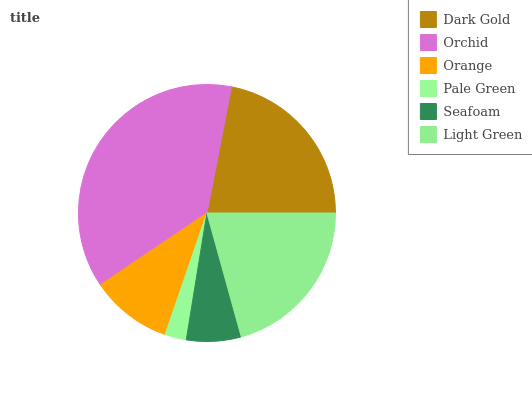Is Pale Green the minimum?
Answer yes or no. Yes. Is Orchid the maximum?
Answer yes or no. Yes. Is Orange the minimum?
Answer yes or no. No. Is Orange the maximum?
Answer yes or no. No. Is Orchid greater than Orange?
Answer yes or no. Yes. Is Orange less than Orchid?
Answer yes or no. Yes. Is Orange greater than Orchid?
Answer yes or no. No. Is Orchid less than Orange?
Answer yes or no. No. Is Light Green the high median?
Answer yes or no. Yes. Is Orange the low median?
Answer yes or no. Yes. Is Dark Gold the high median?
Answer yes or no. No. Is Orchid the low median?
Answer yes or no. No. 